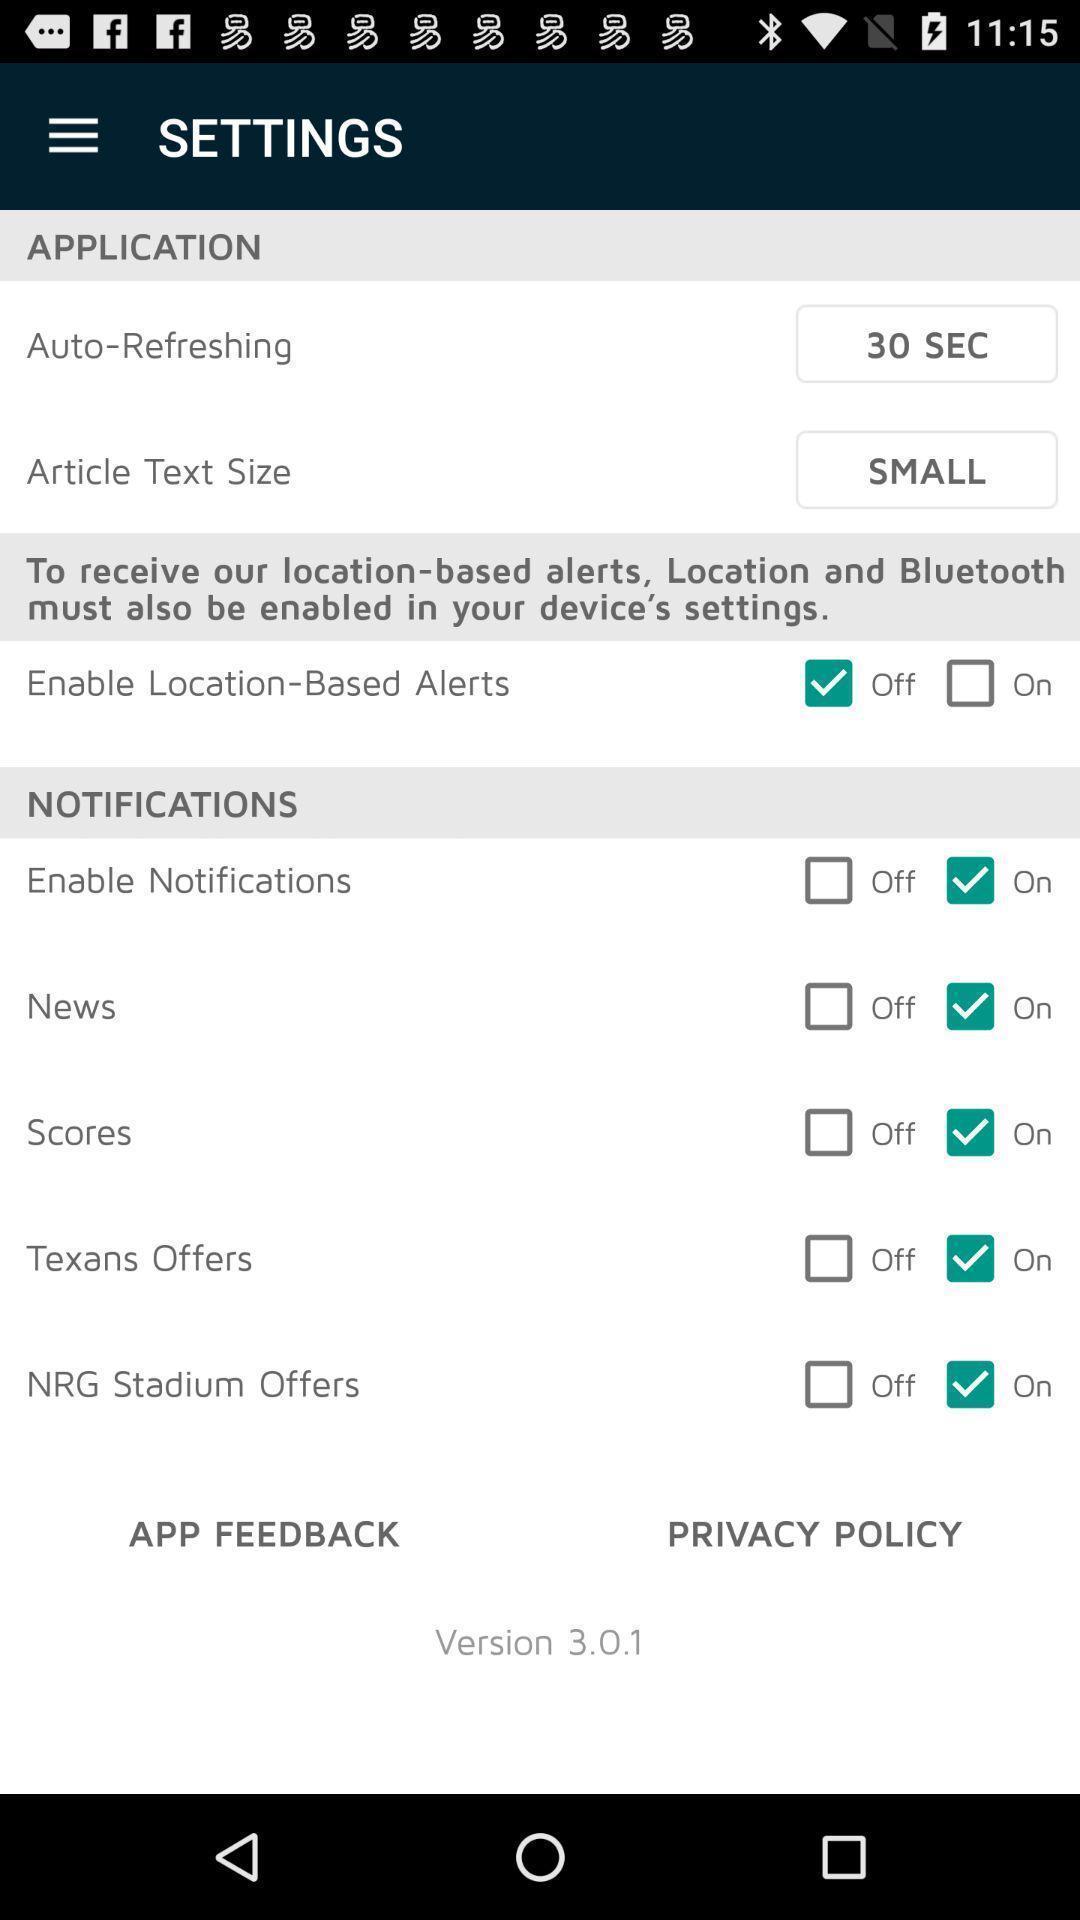Give me a summary of this screen capture. Settings tab in the application with different options. 